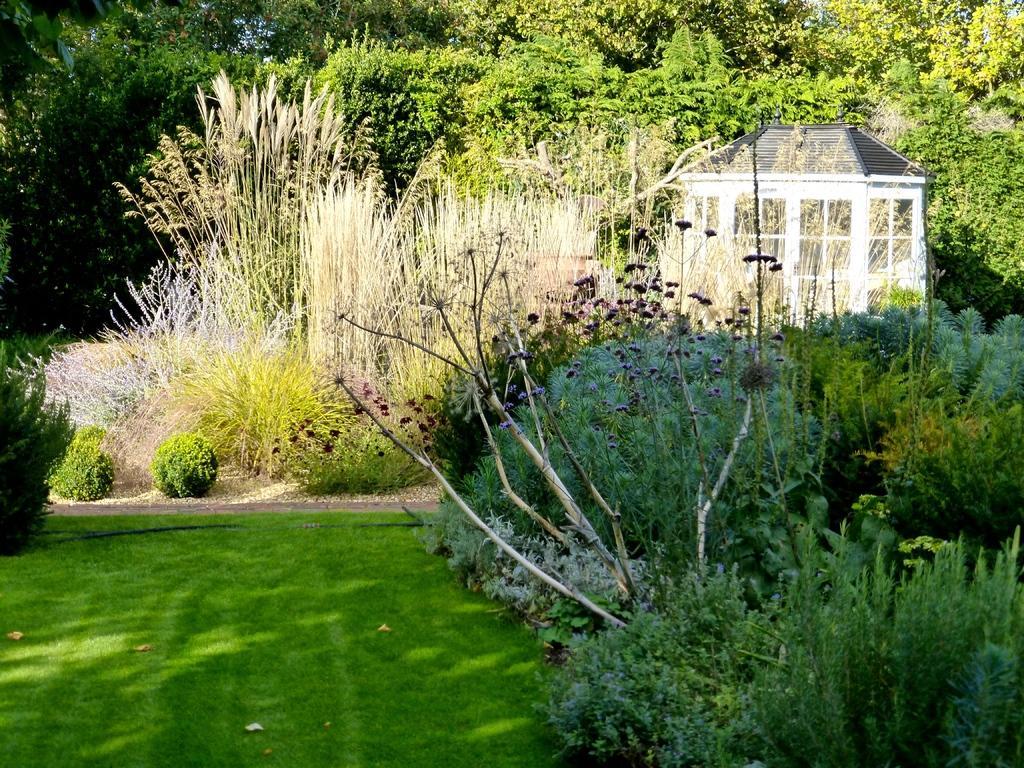Describe this image in one or two sentences. In this picture we can observe some plants on the ground. There is some grass. We can observe trees in the background. On the right side there is a cabin. 